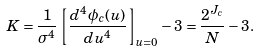Convert formula to latex. <formula><loc_0><loc_0><loc_500><loc_500>K = \frac { 1 } { \sigma ^ { 4 } } \left [ \frac { d ^ { 4 } \phi _ { c } ( u ) } { d u ^ { 4 } } \right ] _ { u = 0 } - 3 = \frac { 2 ^ { J _ { c } } } { N } - 3 .</formula> 